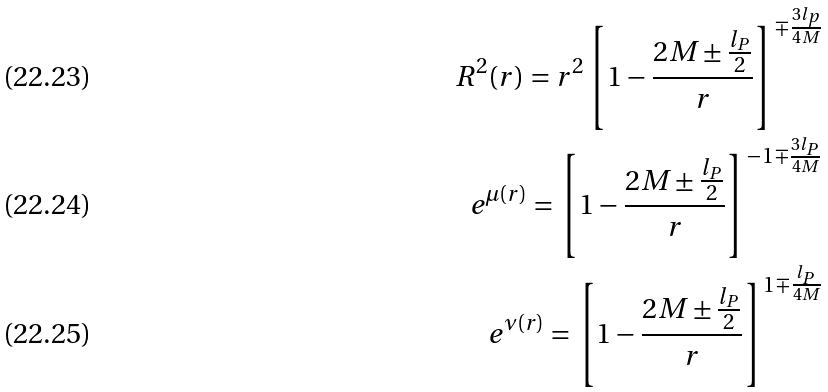<formula> <loc_0><loc_0><loc_500><loc_500>R ^ { 2 } ( r ) = r ^ { 2 } \left [ 1 - \frac { 2 M \pm \frac { l _ { P } } { 2 } } { r } \right ] ^ { \mp \frac { 3 l _ { p } } { 4 M } } \\ e ^ { \mu ( r ) } = \left [ 1 - \frac { 2 M \pm \frac { l _ { P } } { 2 } } { r } \right ] ^ { - 1 \mp \frac { 3 l _ { P } } { 4 M } } \\ e ^ { \nu ( r ) } = \left [ 1 - \frac { 2 M \pm \frac { l _ { P } } { 2 } } { r } \right ] ^ { 1 \mp \frac { l _ { P } } { 4 M } }</formula> 